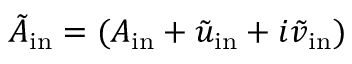Convert formula to latex. <formula><loc_0><loc_0><loc_500><loc_500>\tilde { A } _ { i n } = ( A _ { i n } + \tilde { u } _ { i n } + i \tilde { v } _ { i n } )</formula> 